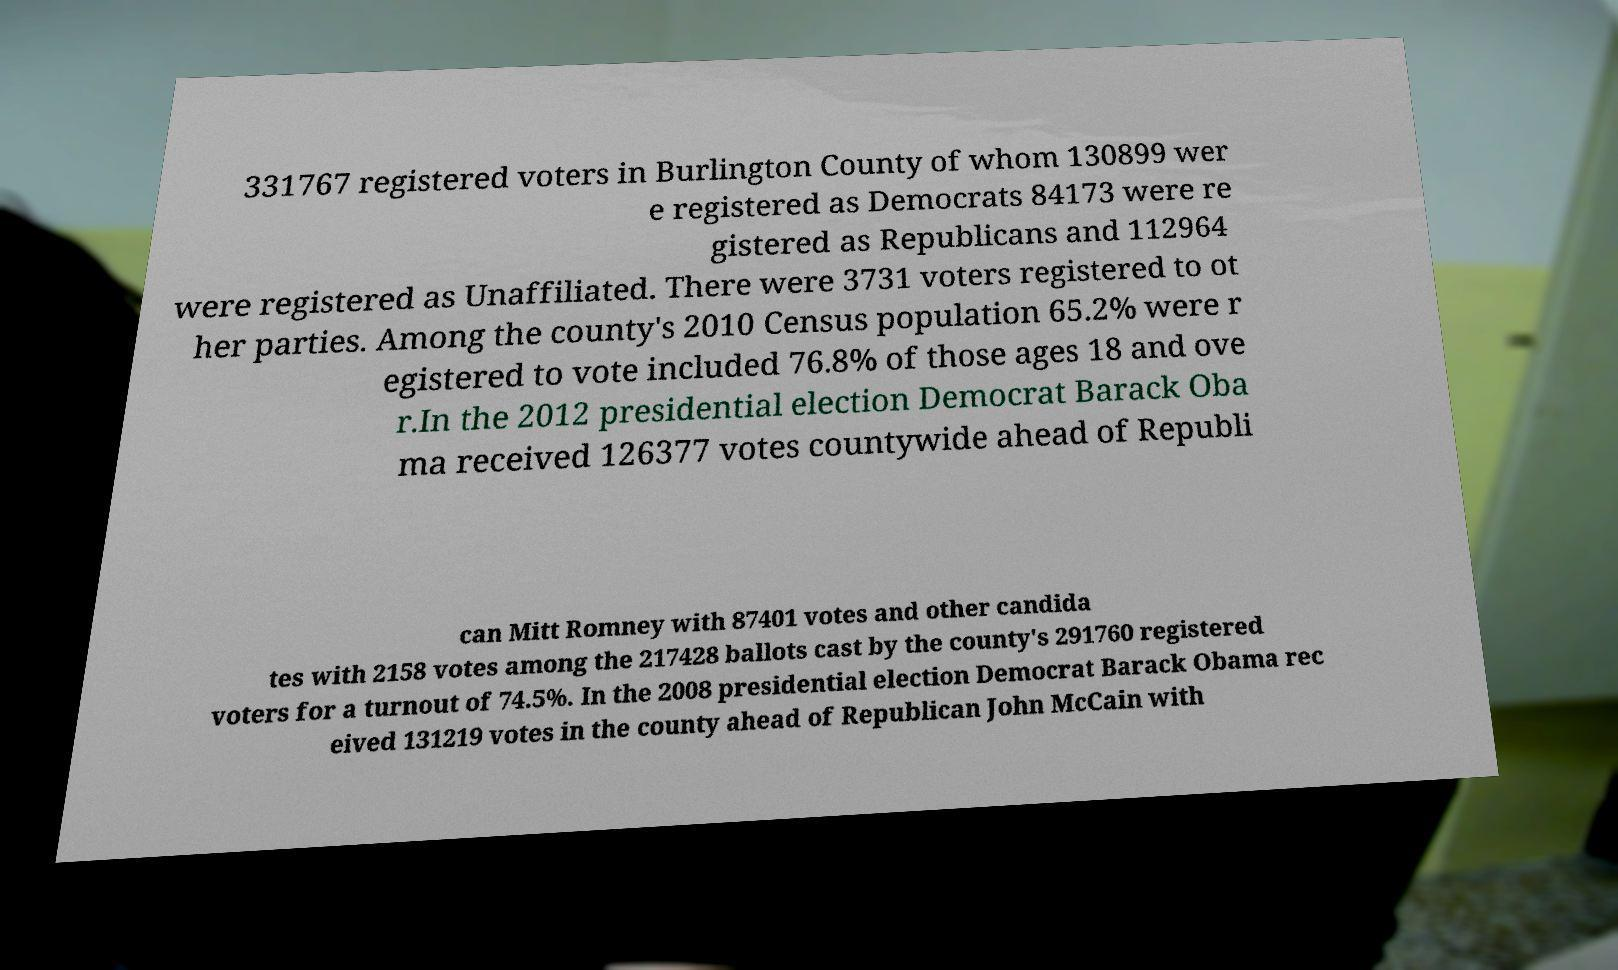There's text embedded in this image that I need extracted. Can you transcribe it verbatim? 331767 registered voters in Burlington County of whom 130899 wer e registered as Democrats 84173 were re gistered as Republicans and 112964 were registered as Unaffiliated. There were 3731 voters registered to ot her parties. Among the county's 2010 Census population 65.2% were r egistered to vote included 76.8% of those ages 18 and ove r.In the 2012 presidential election Democrat Barack Oba ma received 126377 votes countywide ahead of Republi can Mitt Romney with 87401 votes and other candida tes with 2158 votes among the 217428 ballots cast by the county's 291760 registered voters for a turnout of 74.5%. In the 2008 presidential election Democrat Barack Obama rec eived 131219 votes in the county ahead of Republican John McCain with 